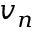Convert formula to latex. <formula><loc_0><loc_0><loc_500><loc_500>v _ { n }</formula> 